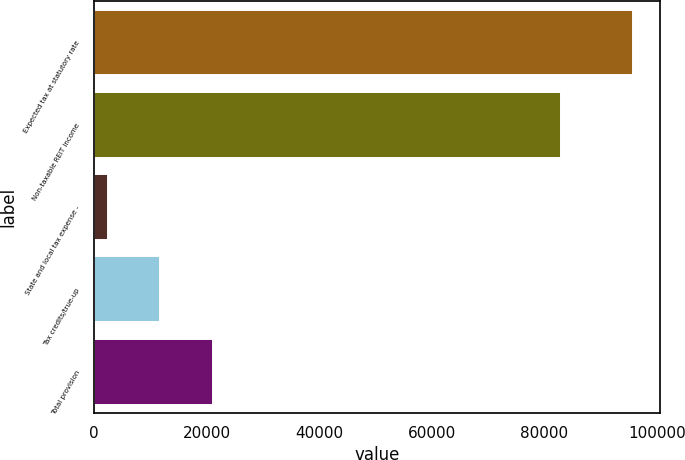<chart> <loc_0><loc_0><loc_500><loc_500><bar_chart><fcel>Expected tax at statutory rate<fcel>Non-taxable REIT income<fcel>State and local tax expense -<fcel>Tax credits/true-up<fcel>Total provision<nl><fcel>95828<fcel>83022<fcel>2385<fcel>11729.3<fcel>21073.6<nl></chart> 